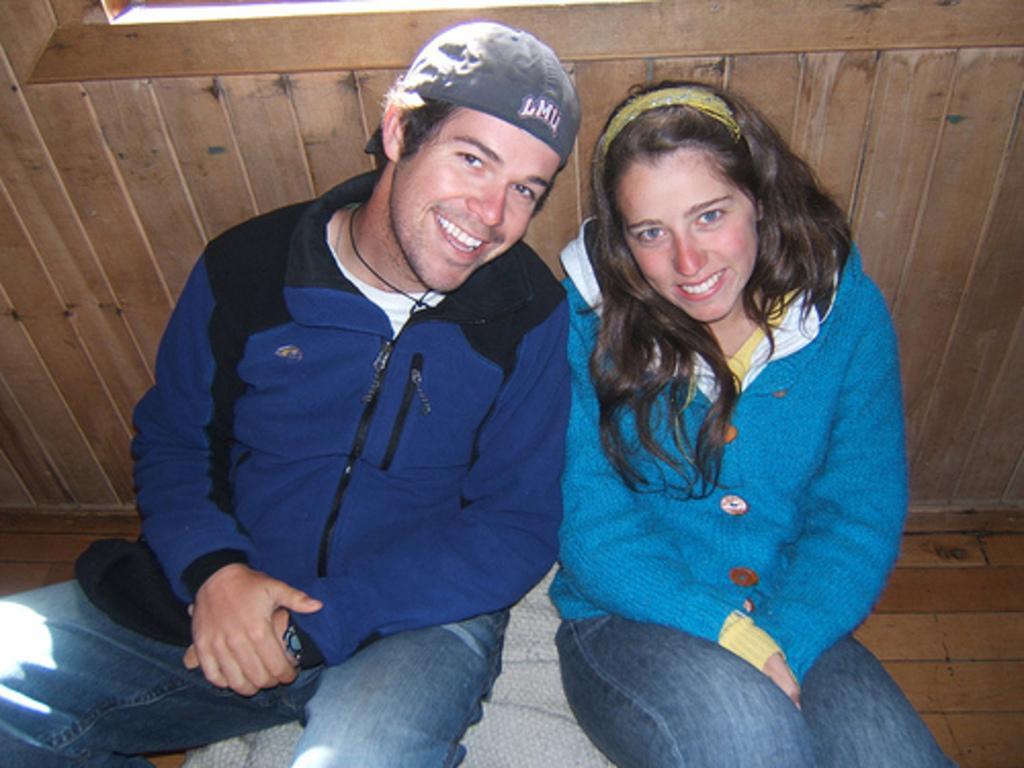Describe this image in one or two sentences. In this image there are two persons sitting on a object,laughing and posing for a picture and there is a wooden object back to them. 